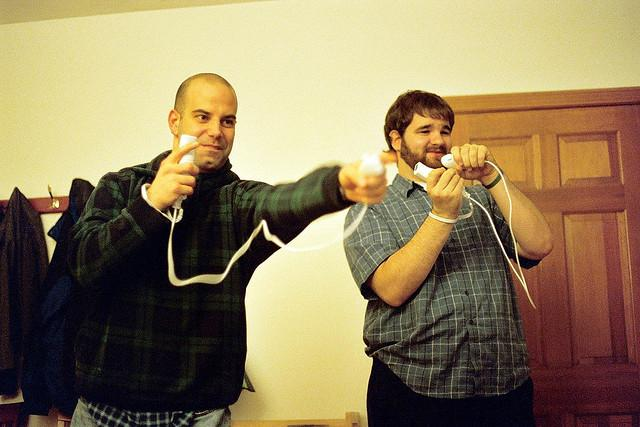What activity is the individual engaging in? Please explain your reasoning. boxing. He is pushing his fist forward like he is punching. 